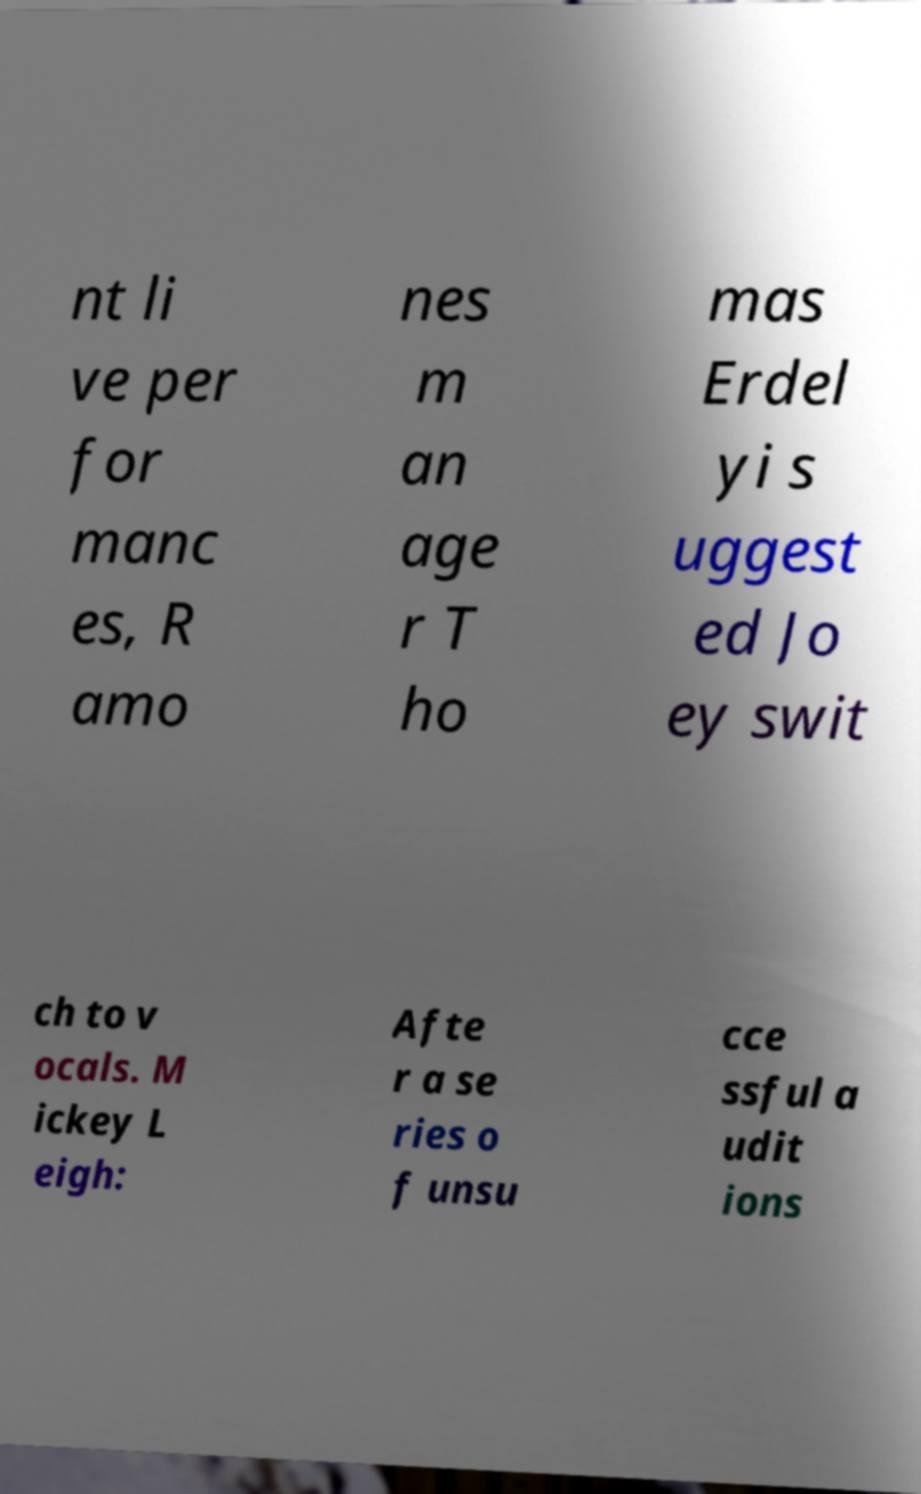Could you extract and type out the text from this image? nt li ve per for manc es, R amo nes m an age r T ho mas Erdel yi s uggest ed Jo ey swit ch to v ocals. M ickey L eigh: Afte r a se ries o f unsu cce ssful a udit ions 